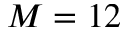<formula> <loc_0><loc_0><loc_500><loc_500>M = 1 2</formula> 